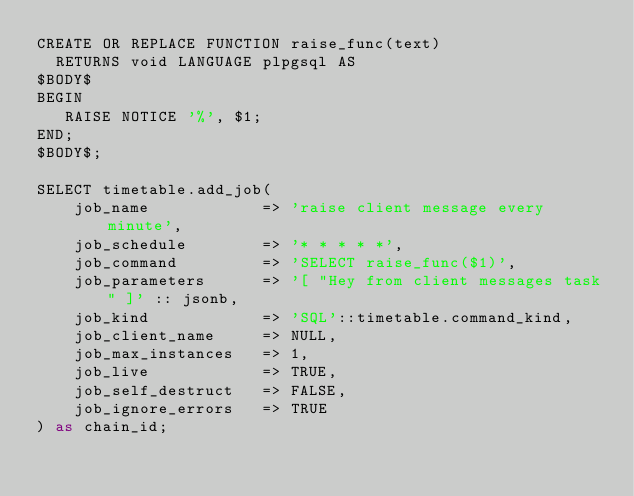Convert code to text. <code><loc_0><loc_0><loc_500><loc_500><_SQL_>CREATE OR REPLACE FUNCTION raise_func(text)
  RETURNS void LANGUAGE plpgsql AS
$BODY$ 
BEGIN 
   RAISE NOTICE '%', $1; 
END; 
$BODY$;

SELECT timetable.add_job(
    job_name            => 'raise client message every minute',
    job_schedule        => '* * * * *',
    job_command         => 'SELECT raise_func($1)',
    job_parameters      => '[ "Hey from client messages task" ]' :: jsonb,
    job_kind            => 'SQL'::timetable.command_kind,
    job_client_name     => NULL,
    job_max_instances   => 1,
    job_live            => TRUE,
    job_self_destruct   => FALSE,
    job_ignore_errors   => TRUE
) as chain_id;</code> 